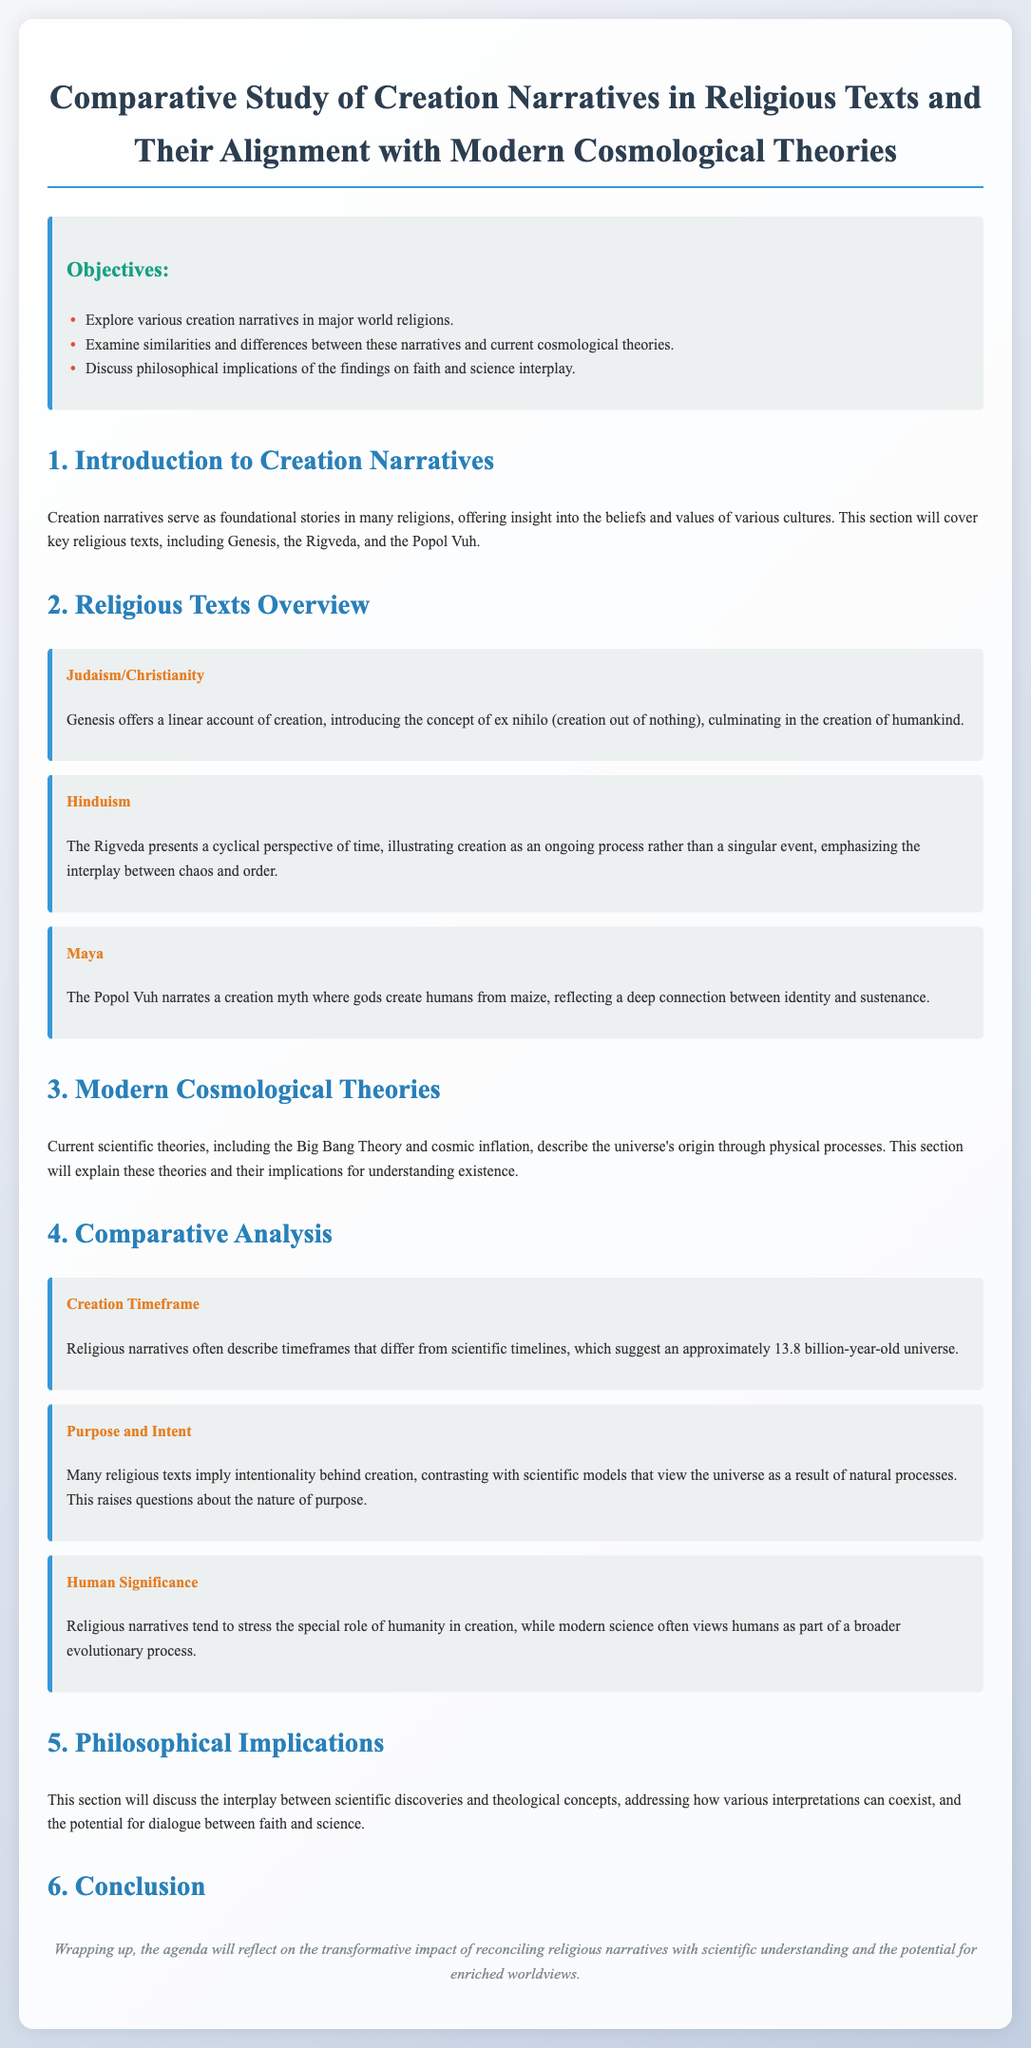What are the major world religions discussed in the document? The document mentions various creation narratives in major world religions including Judaism, Christianity, Hinduism, and Maya.
Answer: Judaism, Christianity, Hinduism, Maya What is the main creation narrative in Judaism and Christianity? According to the document, Genesis offers a linear account of creation introducing the concept of ex nihilo.
Answer: Genesis What is the perspective of creation in the Rigveda? The Rigveda presents a cyclical perspective of time, illustrating creation as an ongoing process rather than a singular event.
Answer: Cyclical perspective How old is the universe according to scientific timelines? The document states that scientific timelines suggest an approximately 13.8 billion-year-old universe.
Answer: 13.8 billion years What does the document imply about the intentionality of creation in religious texts? It implies that many religious texts suggest intentionality behind creation, contrasting with scientific models that view it as natural processes.
Answer: Intentionality What philosophical themes are explored in the document? The document discusses philosophical implications including the interplay between scientific discoveries and theological concepts.
Answer: Interplay between science and theology How does the document categorize the human role in creation? It categorizes that religious narratives tend to stress the special role of humanity, while science often views humans as part of a broader evolutionary process.
Answer: Special role vs. evolutionary process What is the conclusion of the agenda? The conclusion reflects on the transformative impact of reconciling religious narratives with scientific understanding.
Answer: Transformative impact 